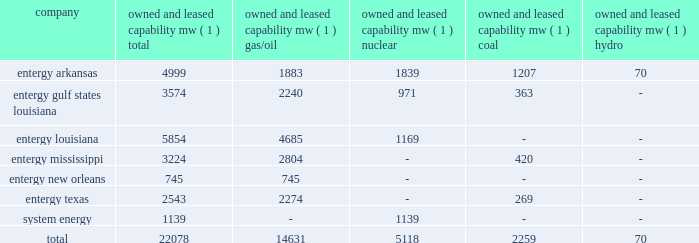Part i item 1 entergy corporation , utility operating companies , and system energy louisiana parishes in which it holds non-exclusive franchises .
Entergy louisiana's electric franchises expire during 2009-2036 .
Entergy mississippi has received from the mpsc certificates of public convenience and necessity to provide electric service to areas within 45 counties , including a number of municipalities , in western mississippi .
Under mississippi statutory law , such certificates are exclusive .
Entergy mississippi may continue to serve in such municipalities upon payment of a statutory franchise fee , regardless of whether an original municipal franchise is still in existence .
Entergy new orleans provides electric and gas service in the city of new orleans pursuant to city ordinances ( except electric service in algiers , which is provided by entergy louisiana ) .
These ordinances contain a continuing option for the city of new orleans to purchase entergy new orleans' electric and gas utility properties .
Entergy texas holds a certificate of convenience and necessity from the puct to provide electric service to areas within approximately 24 counties in eastern texas , and holds non-exclusive franchises to provide electric service in approximately 65 incorporated municipalities .
Entergy texas typically is granted 50-year franchises .
Entergy texas' electric franchises expire during 2009-2045 .
The business of system energy is limited to wholesale power sales .
It has no distribution franchises .
Property and other generation resources generating stations the total capability of the generating stations owned and leased by the utility operating companies and system energy as of december 31 , 2008 , is indicated below: .
( 1 ) "owned and leased capability" is the dependable load carrying capability as demonstrated under actual operating conditions based on the primary fuel ( assuming no curtailments ) that each station was designed to utilize .
The entergy system's load and capacity projections are reviewed periodically to assess the need and timing for additional generating capacity and interconnections .
These reviews consider existing and projected demand , the availability and price of power , the location of new load , and the economy .
Summer peak load in the entergy system service territory has averaged 21039 mw from 2002-2008 .
Due to changing use patterns , peak load growth has nearly flattened while annual energy use continues to grow .
In the 2002 time period , the entergy system's long-term capacity resources , allowing for an adequate reserve margin , were approximately 3000 mw less than the total capacity required for peak period demands .
In this time period entergy met its capacity shortages almost entirely through short-term power purchases in the wholesale spot market .
In the fall of 2002 , the entergy system began a program to add new resources to its existing generation portfolio and began a process of issuing .
What percent of the total owned and leased capability is from nuclear? 
Rationale: you could do averages here but there aren't enough spaces to do that
Computations: (5118 / 22078)
Answer: 0.23181. 